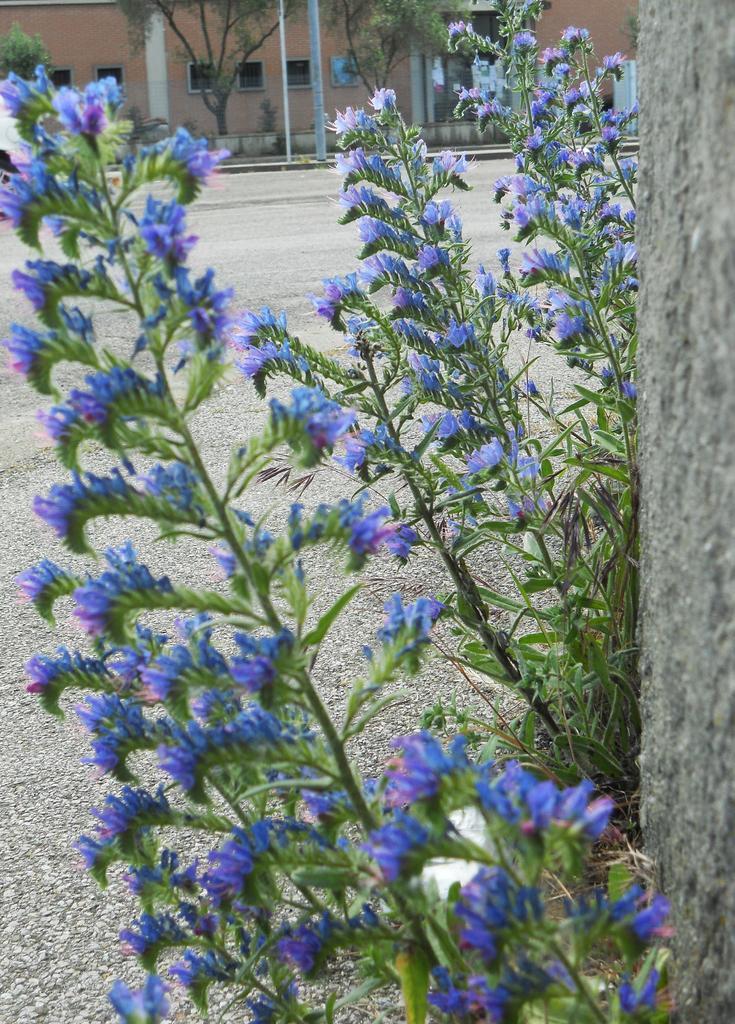Could you give a brief overview of what you see in this image? In this image in the foreground there are some plants and flowers, and on the right side there is a wall. At the bottom there is a walkway, and in the background there are buildings, trees and poles. 